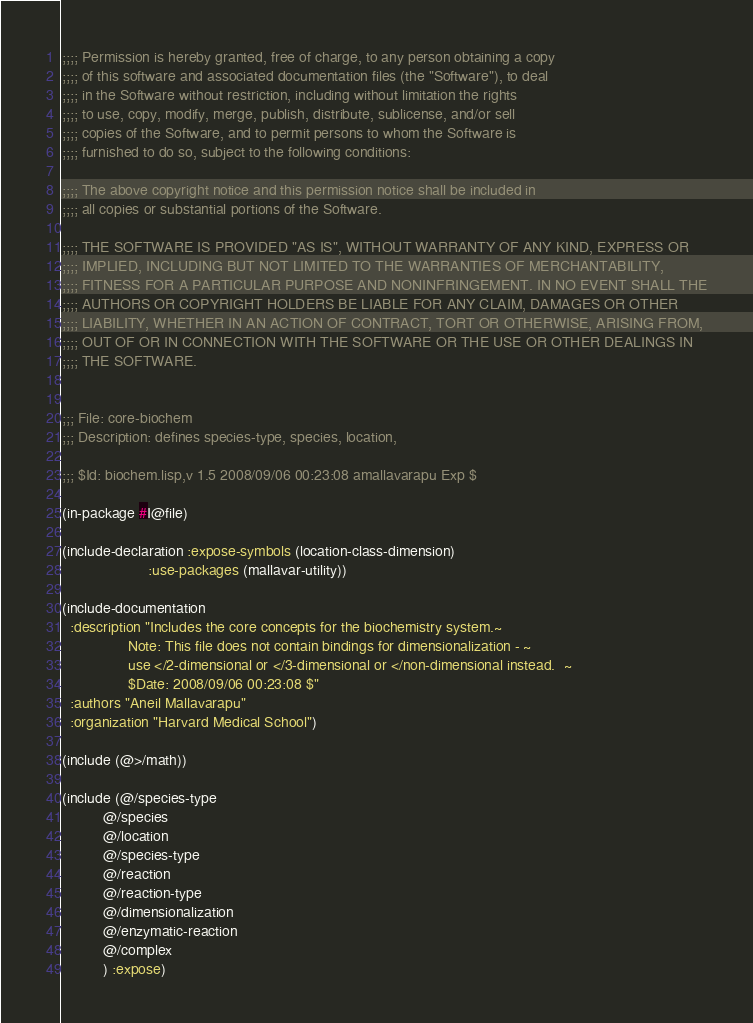<code> <loc_0><loc_0><loc_500><loc_500><_Lisp_>;;;; Permission is hereby granted, free of charge, to any person obtaining a copy
;;;; of this software and associated documentation files (the "Software"), to deal
;;;; in the Software without restriction, including without limitation the rights
;;;; to use, copy, modify, merge, publish, distribute, sublicense, and/or sell
;;;; copies of the Software, and to permit persons to whom the Software is
;;;; furnished to do so, subject to the following conditions:

;;;; The above copyright notice and this permission notice shall be included in
;;;; all copies or substantial portions of the Software.

;;;; THE SOFTWARE IS PROVIDED "AS IS", WITHOUT WARRANTY OF ANY KIND, EXPRESS OR
;;;; IMPLIED, INCLUDING BUT NOT LIMITED TO THE WARRANTIES OF MERCHANTABILITY,
;;;; FITNESS FOR A PARTICULAR PURPOSE AND NONINFRINGEMENT. IN NO EVENT SHALL THE
;;;; AUTHORS OR COPYRIGHT HOLDERS BE LIABLE FOR ANY CLAIM, DAMAGES OR OTHER
;;;; LIABILITY, WHETHER IN AN ACTION OF CONTRACT, TORT OR OTHERWISE, ARISING FROM,
;;;; OUT OF OR IN CONNECTION WITH THE SOFTWARE OR THE USE OR OTHER DEALINGS IN
;;;; THE SOFTWARE.


;;; File: core-biochem
;;; Description: defines species-type, species, location, 

;;; $Id: biochem.lisp,v 1.5 2008/09/06 00:23:08 amallavarapu Exp $

(in-package #I@file)

(include-declaration :expose-symbols (location-class-dimension)
                     :use-packages (mallavar-utility))
 
(include-documentation
  :description "Includes the core concepts for the biochemistry system.~
                Note: This file does not contain bindings for dimensionalization - ~
                use </2-dimensional or </3-dimensional or </non-dimensional instead.  ~
                $Date: 2008/09/06 00:23:08 $"
  :authors "Aneil Mallavarapu"
  :organization "Harvard Medical School")

(include (@>/math))

(include (@/species-type
          @/species 
          @/location 
          @/species-type 
          @/reaction 
          @/reaction-type
          @/dimensionalization
          @/enzymatic-reaction
          @/complex
          ) :expose)

</code> 